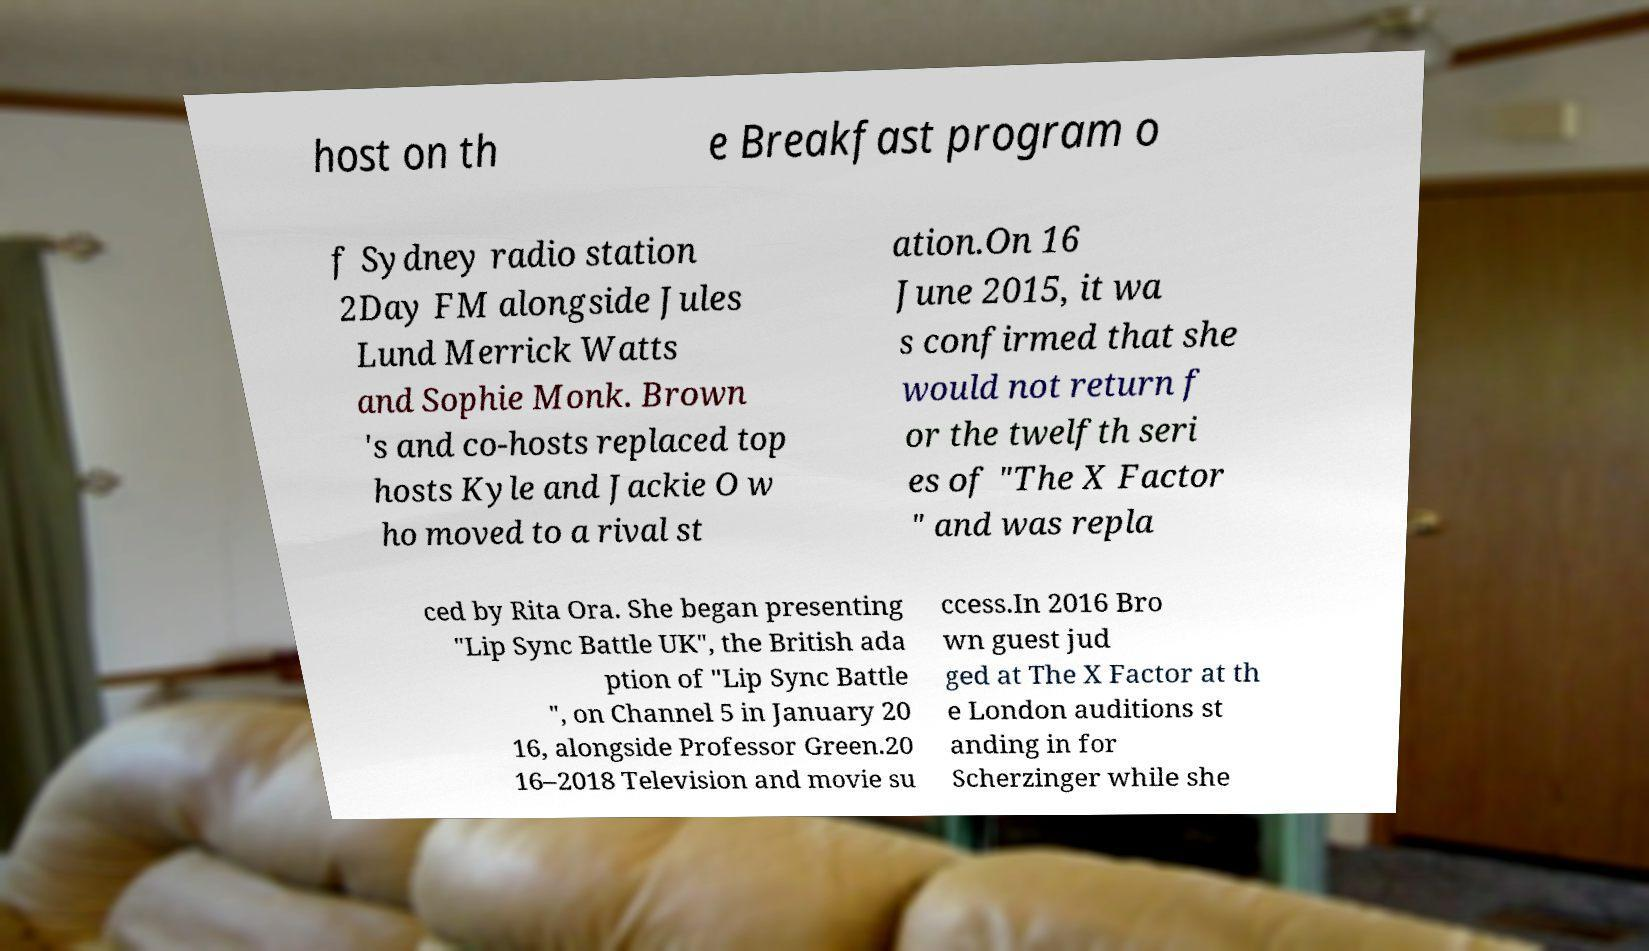Can you accurately transcribe the text from the provided image for me? host on th e Breakfast program o f Sydney radio station 2Day FM alongside Jules Lund Merrick Watts and Sophie Monk. Brown 's and co-hosts replaced top hosts Kyle and Jackie O w ho moved to a rival st ation.On 16 June 2015, it wa s confirmed that she would not return f or the twelfth seri es of "The X Factor " and was repla ced by Rita Ora. She began presenting "Lip Sync Battle UK", the British ada ption of "Lip Sync Battle ", on Channel 5 in January 20 16, alongside Professor Green.20 16–2018 Television and movie su ccess.In 2016 Bro wn guest jud ged at The X Factor at th e London auditions st anding in for Scherzinger while she 